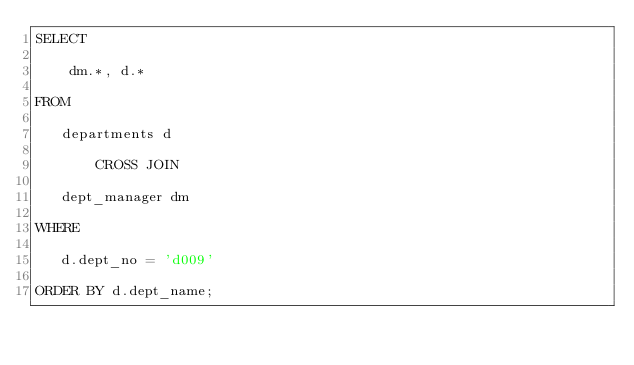Convert code to text. <code><loc_0><loc_0><loc_500><loc_500><_SQL_>SELECT

    dm.*, d.*

FROM

   departments d

       CROSS JOIN

   dept_manager dm

WHERE

   d.dept_no = 'd009'

ORDER BY d.dept_name;
</code> 